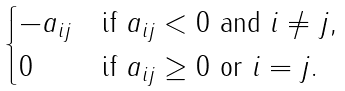<formula> <loc_0><loc_0><loc_500><loc_500>\begin{cases} - a _ { i j } & \text {if } a _ { i j } < 0 \text { and } i \ne j , \\ 0 & \text {if } a _ { i j } \geq 0 \text { or } i = j . \end{cases}</formula> 